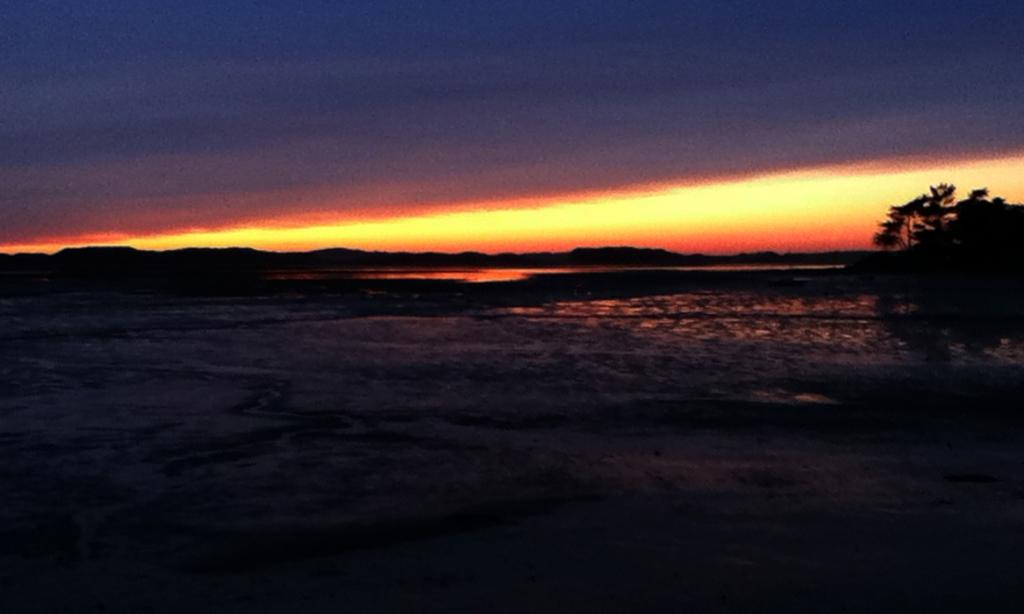What is located on the right side of the image? There is a tree on the right side of the image. What can be seen in the background of the image? The image includes a sunset view. What type of pie is being served at the sunset in the image? There is no pie present in the image; it features a tree and a sunset view. 